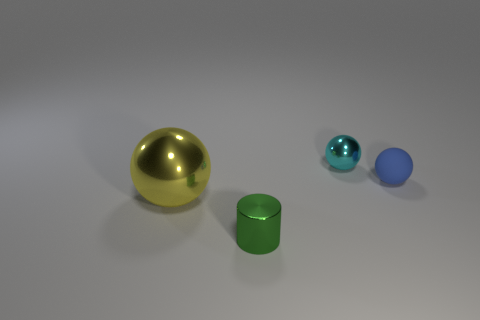The cyan metal ball has what size?
Keep it short and to the point. Small. What is the material of the small blue thing that is to the right of the tiny shiny thing that is on the left side of the tiny metal thing that is behind the big metallic thing?
Offer a terse response. Rubber. How many other things are the same color as the big metallic sphere?
Keep it short and to the point. 0. What number of blue things are rubber balls or metallic spheres?
Provide a succinct answer. 1. What is the small thing right of the tiny metal ball made of?
Your answer should be compact. Rubber. Does the yellow sphere that is to the left of the green shiny object have the same material as the tiny blue ball?
Give a very brief answer. No. What is the shape of the blue rubber object?
Give a very brief answer. Sphere. There is a tiny object that is in front of the sphere on the left side of the tiny cyan object; how many green objects are right of it?
Your answer should be very brief. 0. What number of other objects are there of the same material as the tiny blue thing?
Ensure brevity in your answer.  0. What material is the cyan ball that is the same size as the blue ball?
Make the answer very short. Metal. 